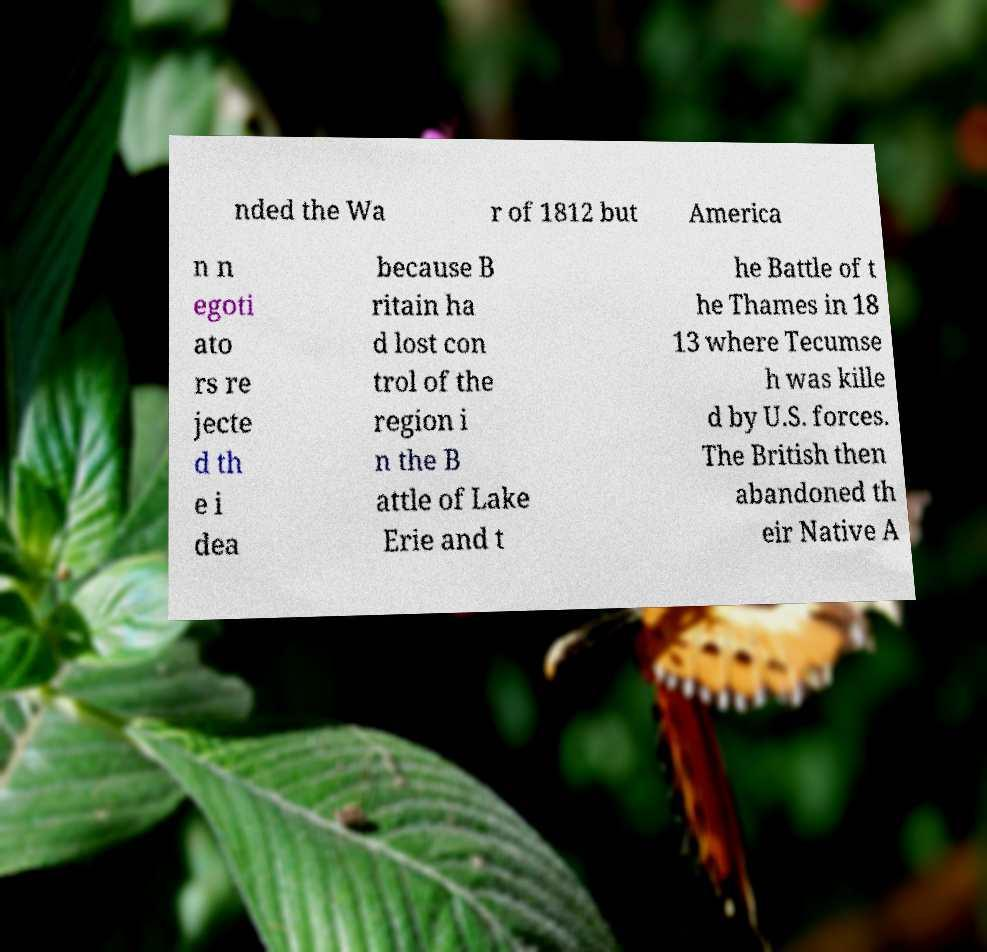There's text embedded in this image that I need extracted. Can you transcribe it verbatim? nded the Wa r of 1812 but America n n egoti ato rs re jecte d th e i dea because B ritain ha d lost con trol of the region i n the B attle of Lake Erie and t he Battle of t he Thames in 18 13 where Tecumse h was kille d by U.S. forces. The British then abandoned th eir Native A 